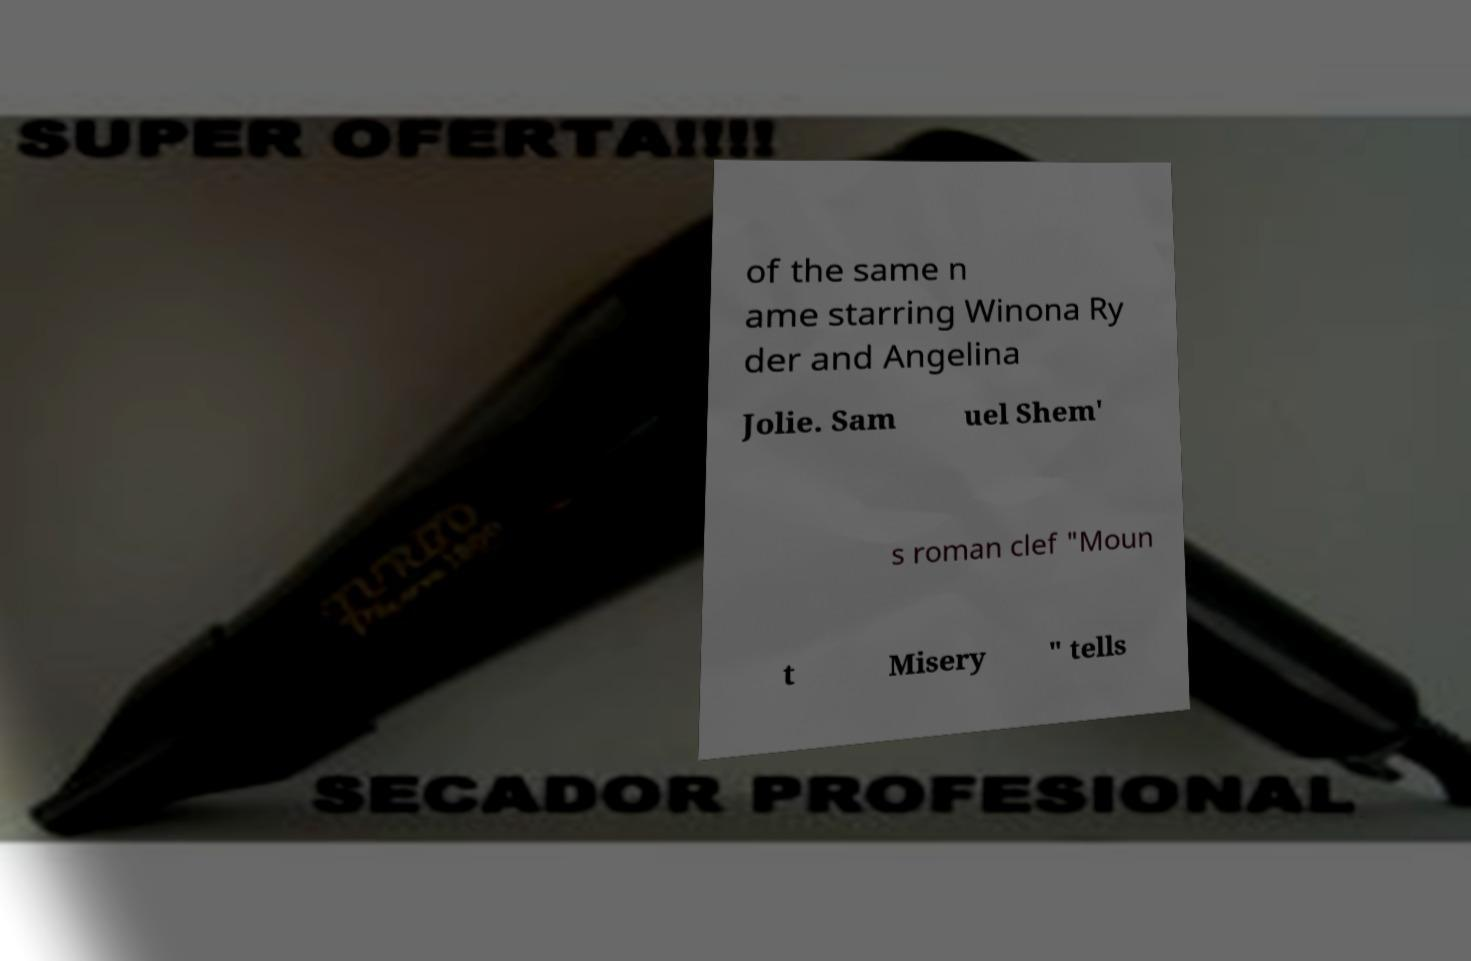Can you read and provide the text displayed in the image?This photo seems to have some interesting text. Can you extract and type it out for me? of the same n ame starring Winona Ry der and Angelina Jolie. Sam uel Shem' s roman clef "Moun t Misery " tells 